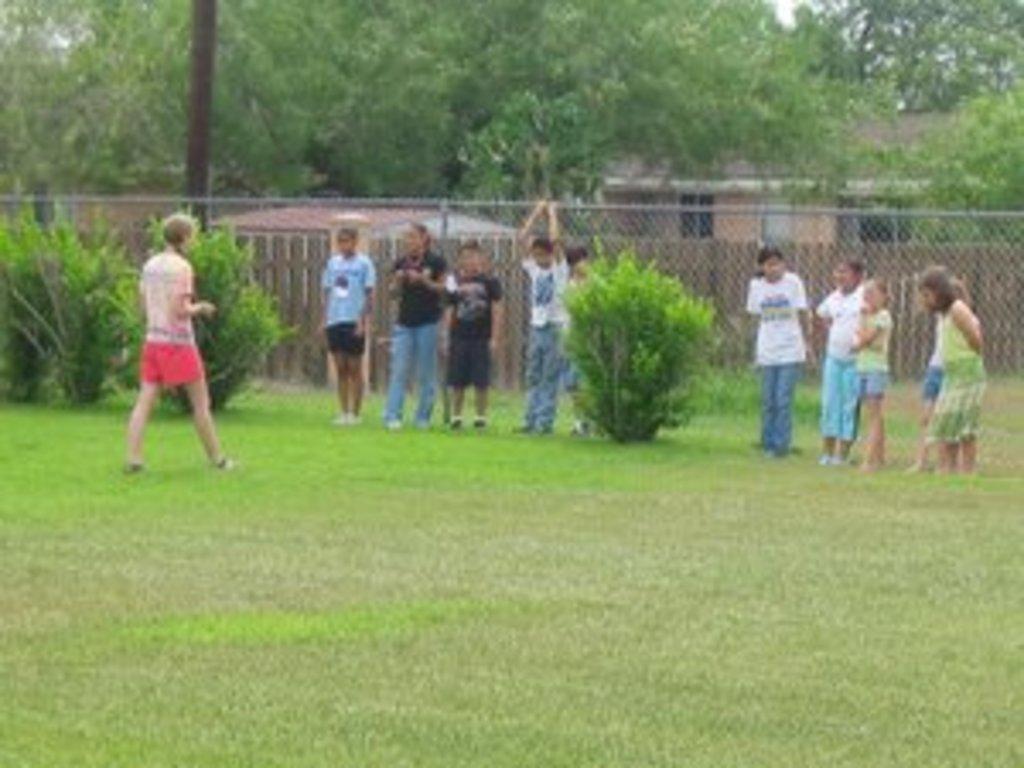How would you summarize this image in a sentence or two? In this picture we can see some people standing here, at the bottom there is grass, we can see fencing here, there are some trees in the background, there is a pole here. 